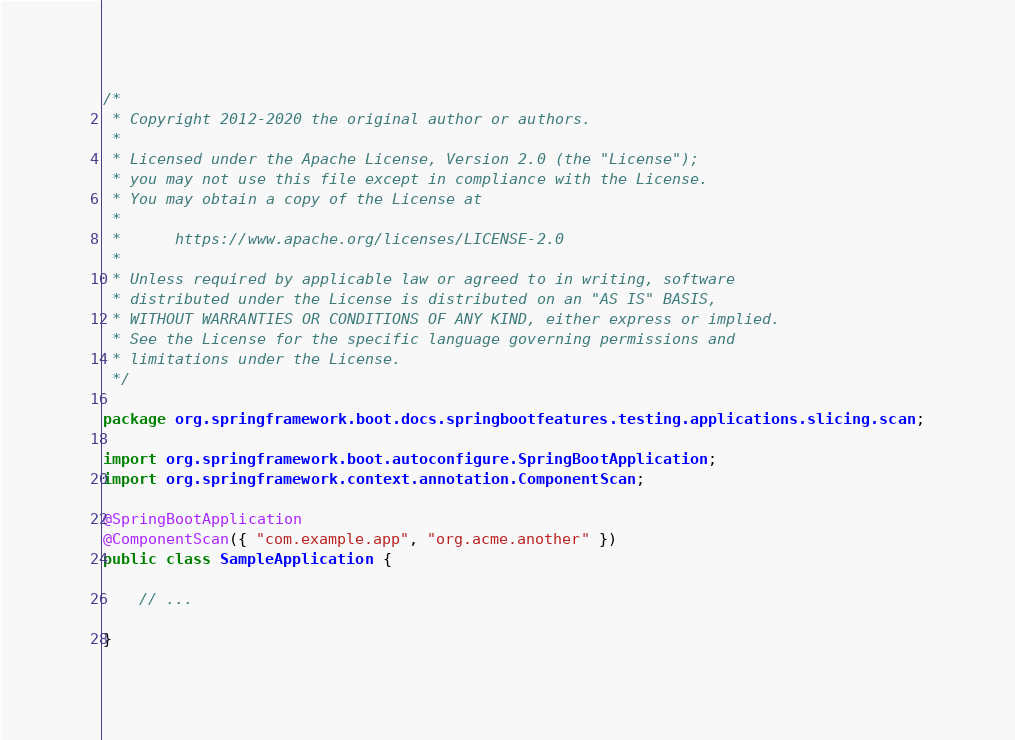Convert code to text. <code><loc_0><loc_0><loc_500><loc_500><_Java_>/*
 * Copyright 2012-2020 the original author or authors.
 *
 * Licensed under the Apache License, Version 2.0 (the "License");
 * you may not use this file except in compliance with the License.
 * You may obtain a copy of the License at
 *
 *      https://www.apache.org/licenses/LICENSE-2.0
 *
 * Unless required by applicable law or agreed to in writing, software
 * distributed under the License is distributed on an "AS IS" BASIS,
 * WITHOUT WARRANTIES OR CONDITIONS OF ANY KIND, either express or implied.
 * See the License for the specific language governing permissions and
 * limitations under the License.
 */

package org.springframework.boot.docs.springbootfeatures.testing.applications.slicing.scan;

import org.springframework.boot.autoconfigure.SpringBootApplication;
import org.springframework.context.annotation.ComponentScan;

@SpringBootApplication
@ComponentScan({ "com.example.app", "org.acme.another" })
public class SampleApplication {

	// ...

}
</code> 